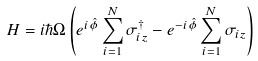<formula> <loc_0><loc_0><loc_500><loc_500>H = i \hbar { \Omega } \left ( e ^ { i \hat { \phi } } \sum _ { i = 1 } ^ { N } \sigma _ { i z } ^ { \dagger } - e ^ { - i \hat { \phi } } \sum _ { i = 1 } ^ { N } \sigma _ { i z } \right )</formula> 